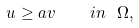Convert formula to latex. <formula><loc_0><loc_0><loc_500><loc_500>u \geq a v \quad i n \ \Omega ,</formula> 